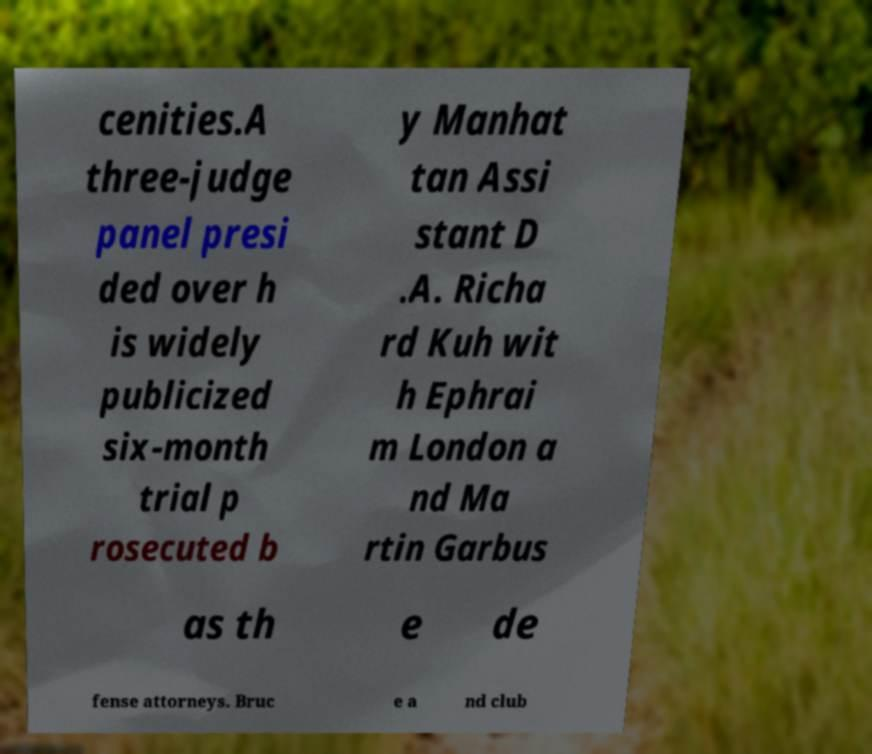There's text embedded in this image that I need extracted. Can you transcribe it verbatim? cenities.A three-judge panel presi ded over h is widely publicized six-month trial p rosecuted b y Manhat tan Assi stant D .A. Richa rd Kuh wit h Ephrai m London a nd Ma rtin Garbus as th e de fense attorneys. Bruc e a nd club 